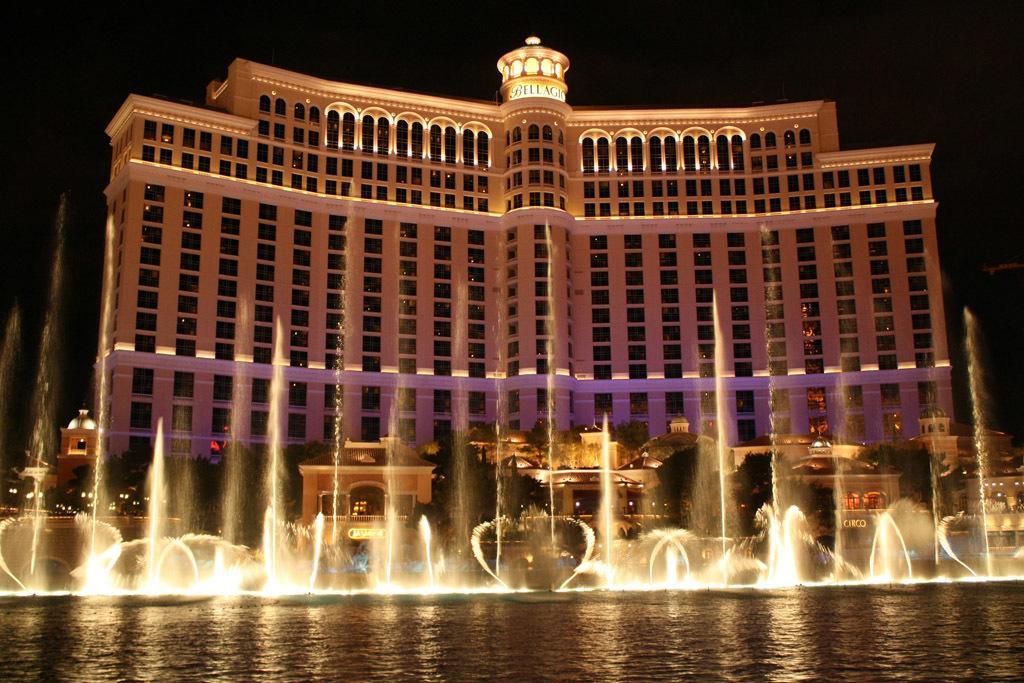Describe this image in one or two sentences. At the bottom of the picture, we see water. In the middle of the picture, we see the fountains. There are buildings in the background. Behind that, we see a palace. In the background, it is black in color. This picture might be clicked in the dark. 